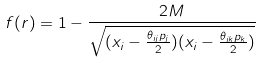<formula> <loc_0><loc_0><loc_500><loc_500>f ( r ) = 1 - \frac { 2 M } { \sqrt { ( x _ { i } - \frac { \theta _ { i j } p _ { j } } { 2 } ) ( x _ { i } - \frac { \theta _ { i k } p _ { k } } { 2 } ) } }</formula> 